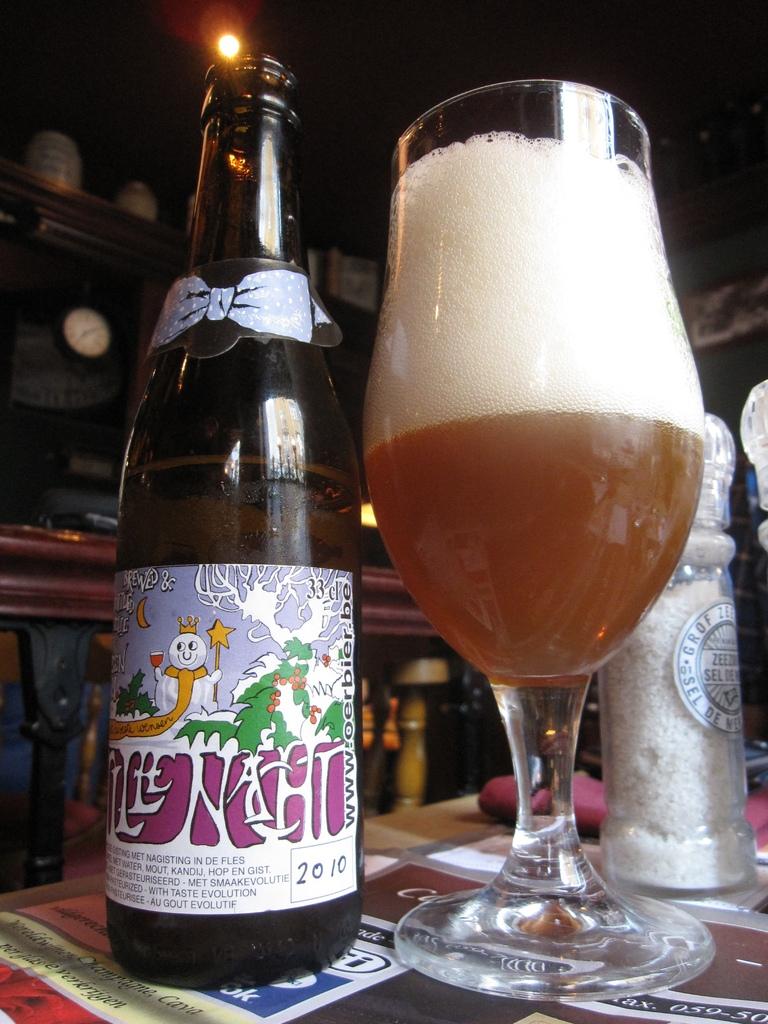What number is in red?
Offer a very short reply. Unanswerable. What year is on the bottle?
Offer a very short reply. 2010. 